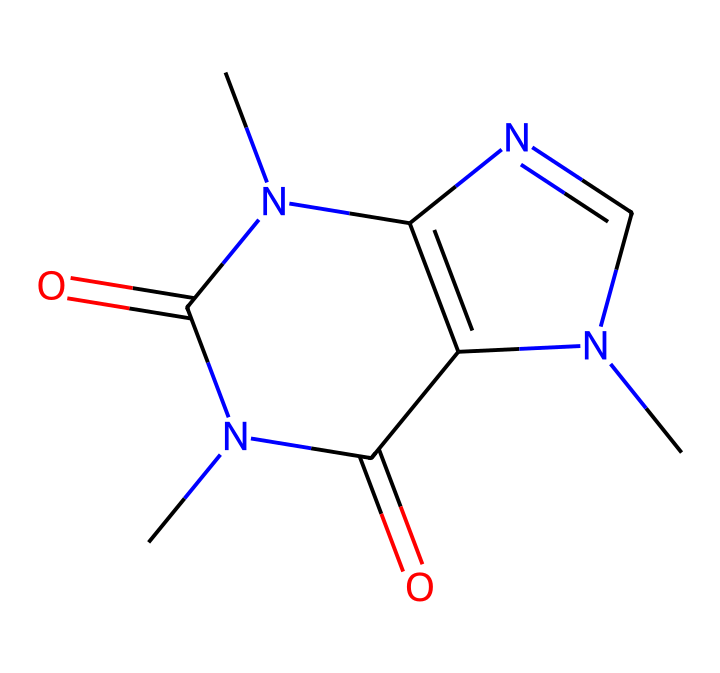What is the molecular formula of caffeine? To determine the molecular formula from the SMILES representation (CN1C=NC2=C1C(=O)N(C(=O)N2C)C), count the atoms of each element present: Carbon (C), Hydrogen (H), Nitrogen (N), and Oxygen (O). There are 8 carbons, 10 hydrogens, 4 nitrogens, and 2 oxygens, which gives us the formula C8H10N4O2.
Answer: C8H10N4O2 How many nitrogen atoms are in the chemical structure? By examining the SMILES representation, I can identify 'N' for the nitrogen atoms. Counting all occurrences of 'N' in the structure shows that there are 4 nitrogen atoms.
Answer: 4 What type of functional groups are present in caffeine? Looking at the chemical structure, the presence of the 'C(=O)' notation indicates carbonyl (ketone or amide) groups, specifically two amide functional groups connected to nitrogen atoms.
Answer: amides What is the total number of rings in the caffeine structure? From the SMILES, I observe two cyclic structures indicated by 'N1' and 'C2', meaning there are two interconnected rings forming a bicyclic compound.
Answer: 2 Which element is primarily responsible for the basic properties of caffeine? The nitrogen atoms ('N') in the structure indicate that caffeine is a basic compound, as they can accept protons due to their lone pair of electrons, which significantly affects its basic properties.
Answer: nitrogen Does caffeine contain any double bonds? Yes, by analyzing the structure, the '=' signs denote double bonds between certain carbon and nitrogen atoms, confirming the presence of double bonds in the caffeine structure.
Answer: yes 